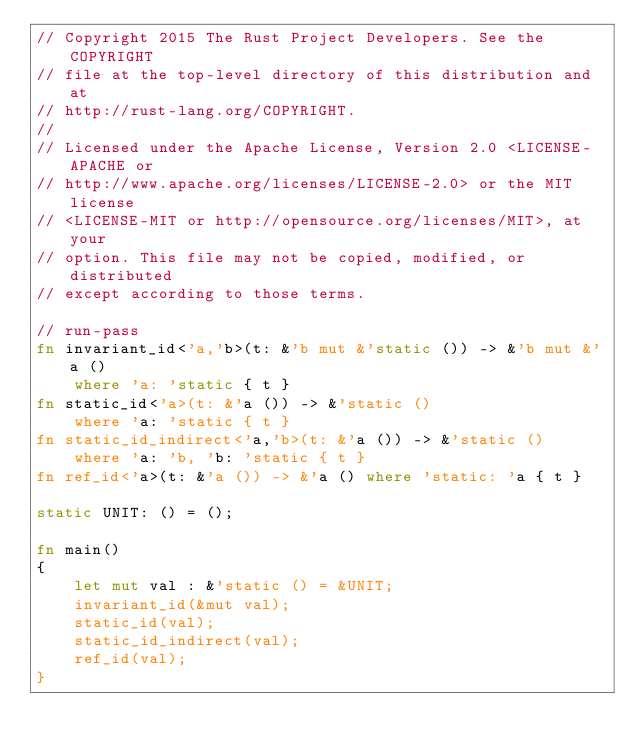<code> <loc_0><loc_0><loc_500><loc_500><_Rust_>// Copyright 2015 The Rust Project Developers. See the COPYRIGHT
// file at the top-level directory of this distribution and at
// http://rust-lang.org/COPYRIGHT.
//
// Licensed under the Apache License, Version 2.0 <LICENSE-APACHE or
// http://www.apache.org/licenses/LICENSE-2.0> or the MIT license
// <LICENSE-MIT or http://opensource.org/licenses/MIT>, at your
// option. This file may not be copied, modified, or distributed
// except according to those terms.

// run-pass
fn invariant_id<'a,'b>(t: &'b mut &'static ()) -> &'b mut &'a ()
    where 'a: 'static { t }
fn static_id<'a>(t: &'a ()) -> &'static ()
    where 'a: 'static { t }
fn static_id_indirect<'a,'b>(t: &'a ()) -> &'static ()
    where 'a: 'b, 'b: 'static { t }
fn ref_id<'a>(t: &'a ()) -> &'a () where 'static: 'a { t }

static UNIT: () = ();

fn main()
{
    let mut val : &'static () = &UNIT;
    invariant_id(&mut val);
    static_id(val);
    static_id_indirect(val);
    ref_id(val);
}
</code> 